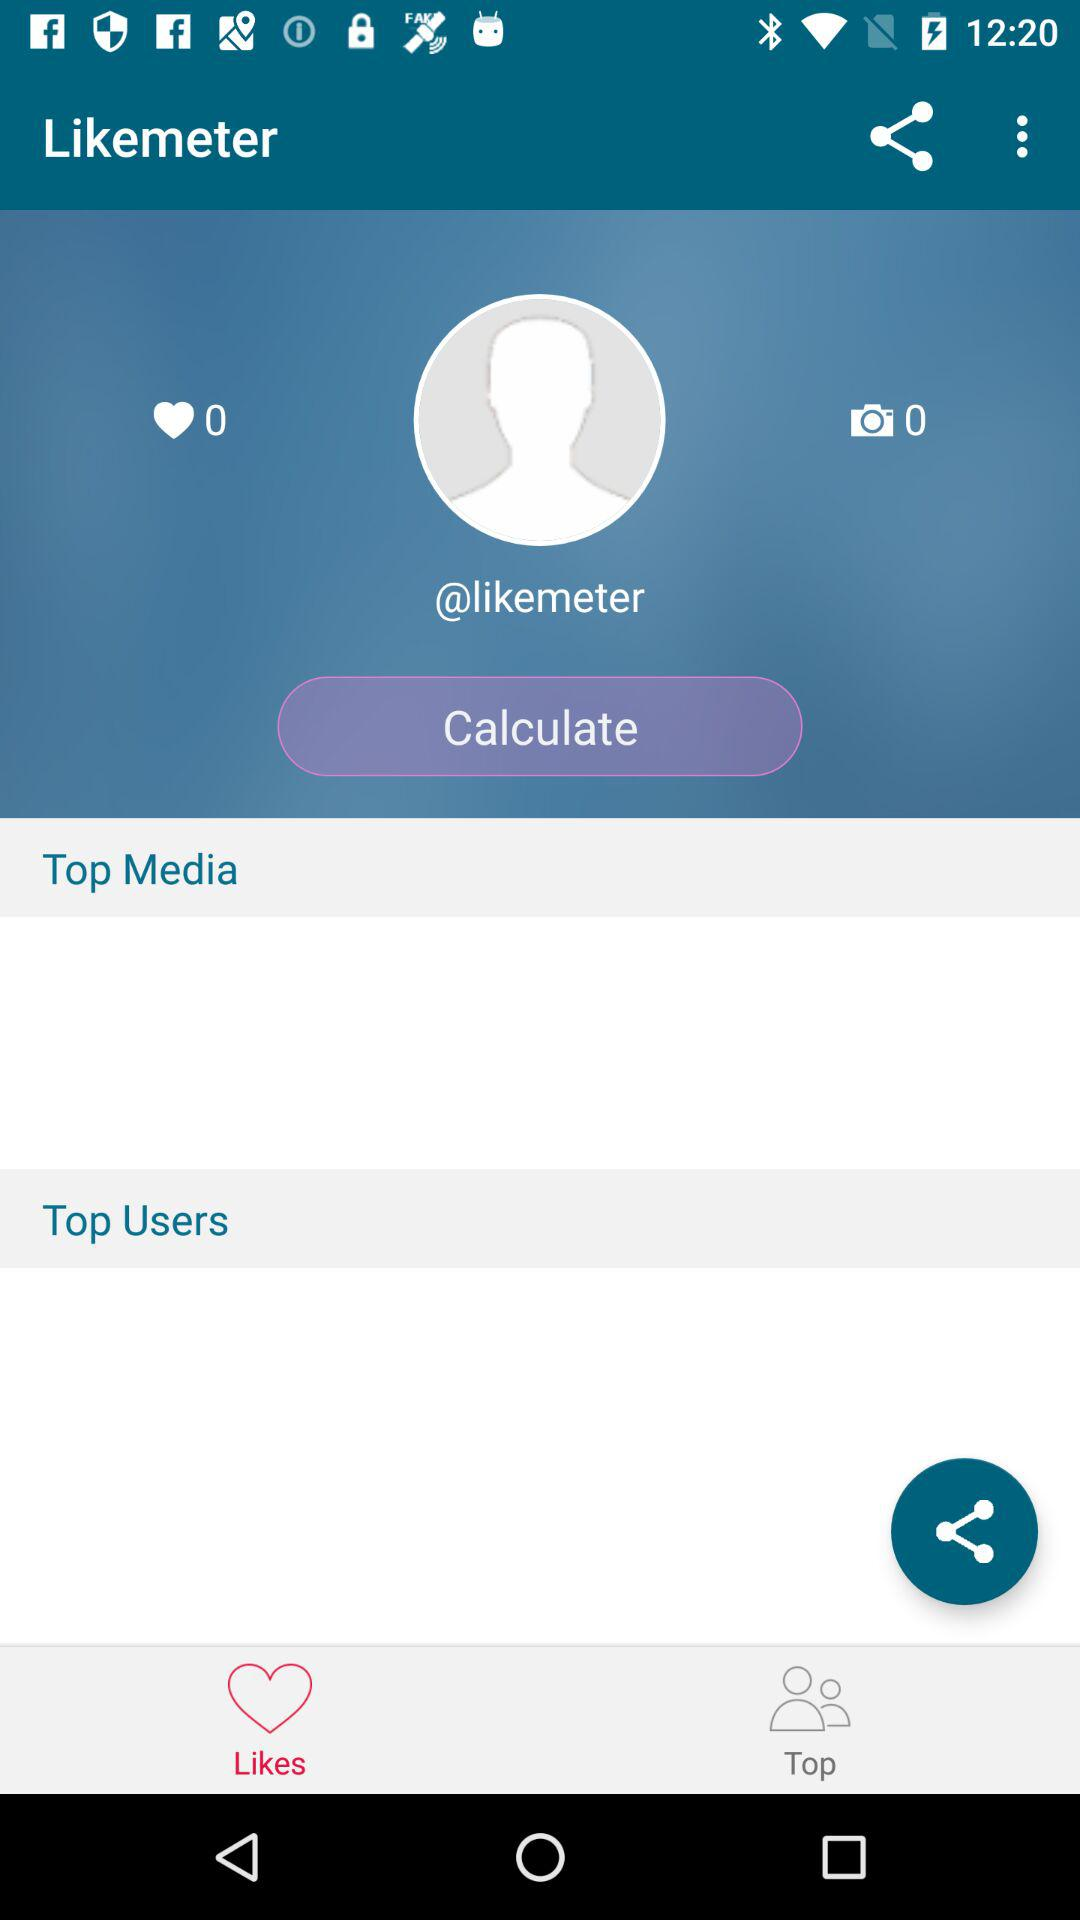What's the username? The username is "@likemeter". 